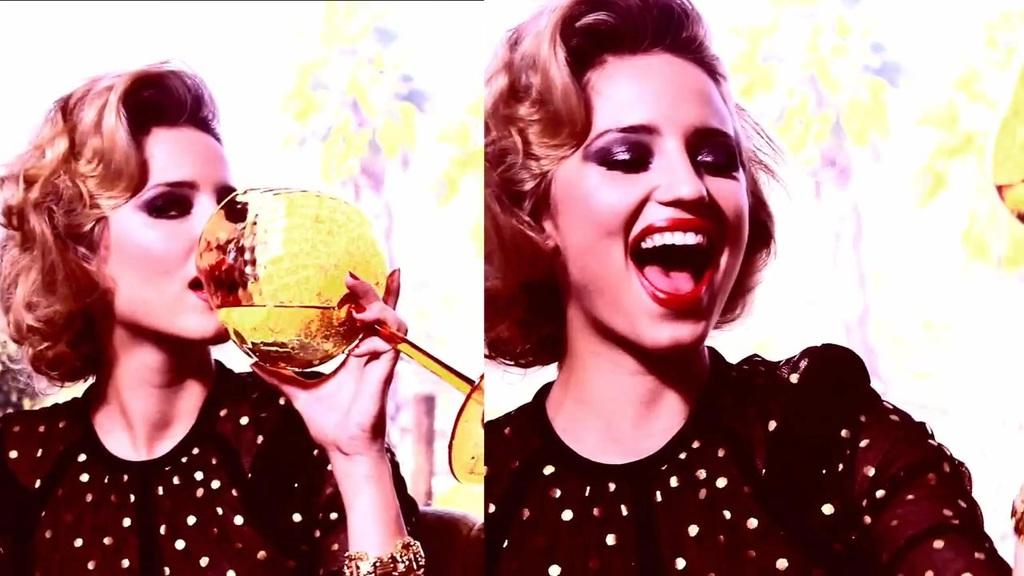What type of artwork is the image? The image is a collage. Can you describe the woman on the left side of the image? There is a woman holding a glass on the left side of the image. What is present on the right side of the image? There is another woman on the right side of the image. What type of creature is the woman on the right side of the image interacting with? There is no creature present in the image; it is a collage featuring two women. What type of exchange is happening between the two women in the image? The image does not show any exchange between the two women; it only shows them in separate positions within the collage. 